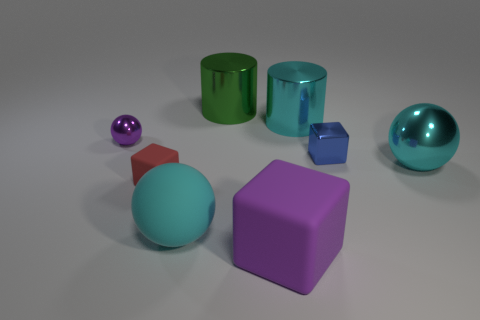Add 2 gray rubber spheres. How many objects exist? 10 Subtract all blocks. How many objects are left? 5 Subtract all large things. Subtract all tiny metallic blocks. How many objects are left? 2 Add 4 tiny blue metal cubes. How many tiny blue metal cubes are left? 5 Add 6 large cylinders. How many large cylinders exist? 8 Subtract 1 purple blocks. How many objects are left? 7 